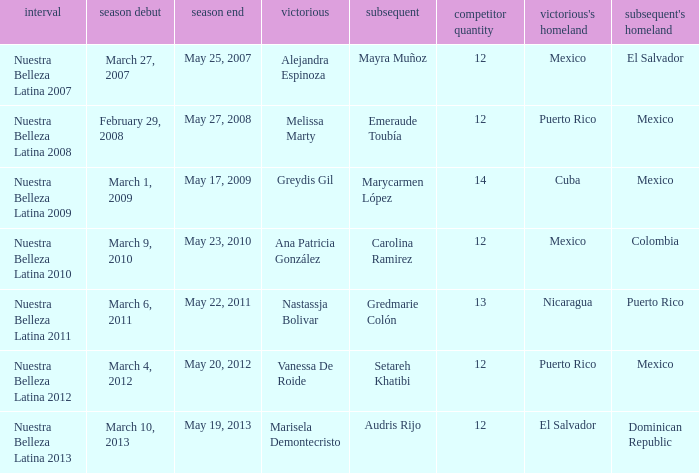How many contestants were there in a season where alejandra espinoza won? 1.0. Give me the full table as a dictionary. {'header': ['interval', 'season debut', 'season end', 'victorious', 'subsequent', 'competitor quantity', "victorious's homeland", "subsequent's homeland"], 'rows': [['Nuestra Belleza Latina 2007', 'March 27, 2007', 'May 25, 2007', 'Alejandra Espinoza', 'Mayra Muñoz', '12', 'Mexico', 'El Salvador'], ['Nuestra Belleza Latina 2008', 'February 29, 2008', 'May 27, 2008', 'Melissa Marty', 'Emeraude Toubía', '12', 'Puerto Rico', 'Mexico'], ['Nuestra Belleza Latina 2009', 'March 1, 2009', 'May 17, 2009', 'Greydis Gil', 'Marycarmen López', '14', 'Cuba', 'Mexico'], ['Nuestra Belleza Latina 2010', 'March 9, 2010', 'May 23, 2010', 'Ana Patricia González', 'Carolina Ramirez', '12', 'Mexico', 'Colombia'], ['Nuestra Belleza Latina 2011', 'March 6, 2011', 'May 22, 2011', 'Nastassja Bolivar', 'Gredmarie Colón', '13', 'Nicaragua', 'Puerto Rico'], ['Nuestra Belleza Latina 2012', 'March 4, 2012', 'May 20, 2012', 'Vanessa De Roide', 'Setareh Khatibi', '12', 'Puerto Rico', 'Mexico'], ['Nuestra Belleza Latina 2013', 'March 10, 2013', 'May 19, 2013', 'Marisela Demontecristo', 'Audris Rijo', '12', 'El Salvador', 'Dominican Republic']]} 